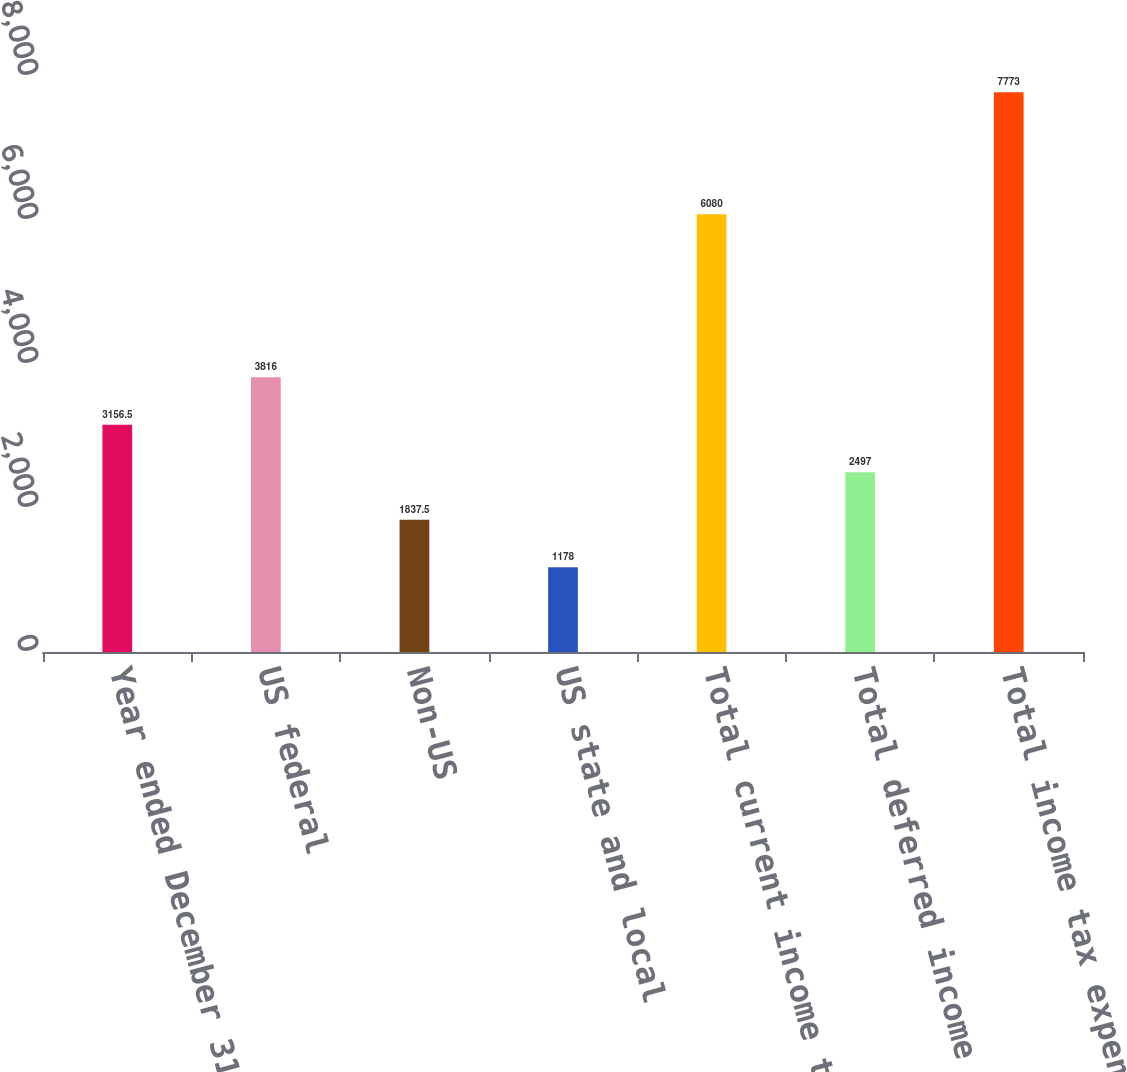Convert chart. <chart><loc_0><loc_0><loc_500><loc_500><bar_chart><fcel>Year ended December 31 (in<fcel>US federal<fcel>Non-US<fcel>US state and local<fcel>Total current income tax<fcel>Total deferred income tax<fcel>Total income tax expense<nl><fcel>3156.5<fcel>3816<fcel>1837.5<fcel>1178<fcel>6080<fcel>2497<fcel>7773<nl></chart> 